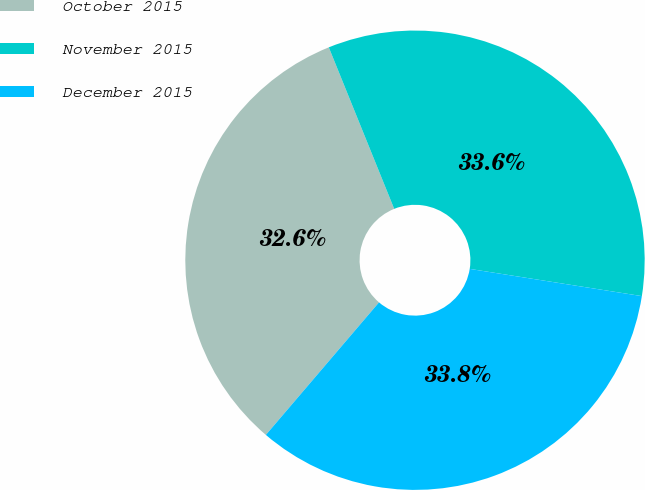Convert chart to OTSL. <chart><loc_0><loc_0><loc_500><loc_500><pie_chart><fcel>October 2015<fcel>November 2015<fcel>December 2015<nl><fcel>32.63%<fcel>33.62%<fcel>33.75%<nl></chart> 